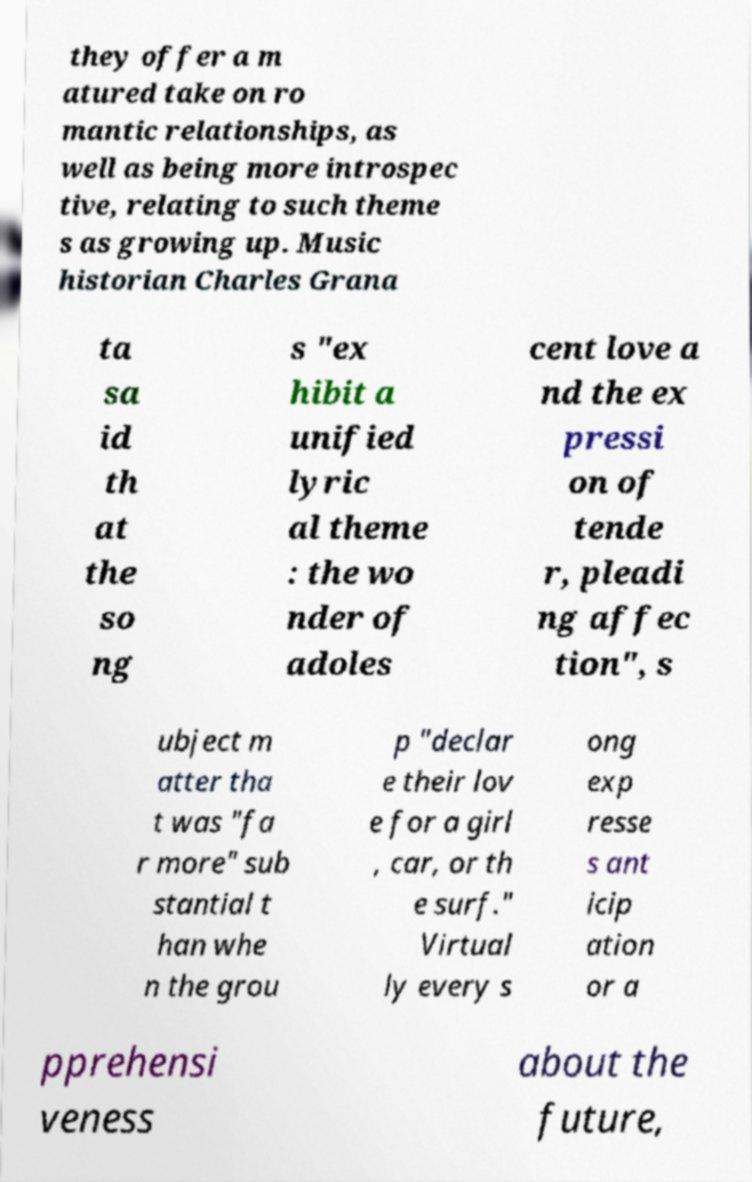Could you assist in decoding the text presented in this image and type it out clearly? they offer a m atured take on ro mantic relationships, as well as being more introspec tive, relating to such theme s as growing up. Music historian Charles Grana ta sa id th at the so ng s "ex hibit a unified lyric al theme : the wo nder of adoles cent love a nd the ex pressi on of tende r, pleadi ng affec tion", s ubject m atter tha t was "fa r more" sub stantial t han whe n the grou p "declar e their lov e for a girl , car, or th e surf." Virtual ly every s ong exp resse s ant icip ation or a pprehensi veness about the future, 